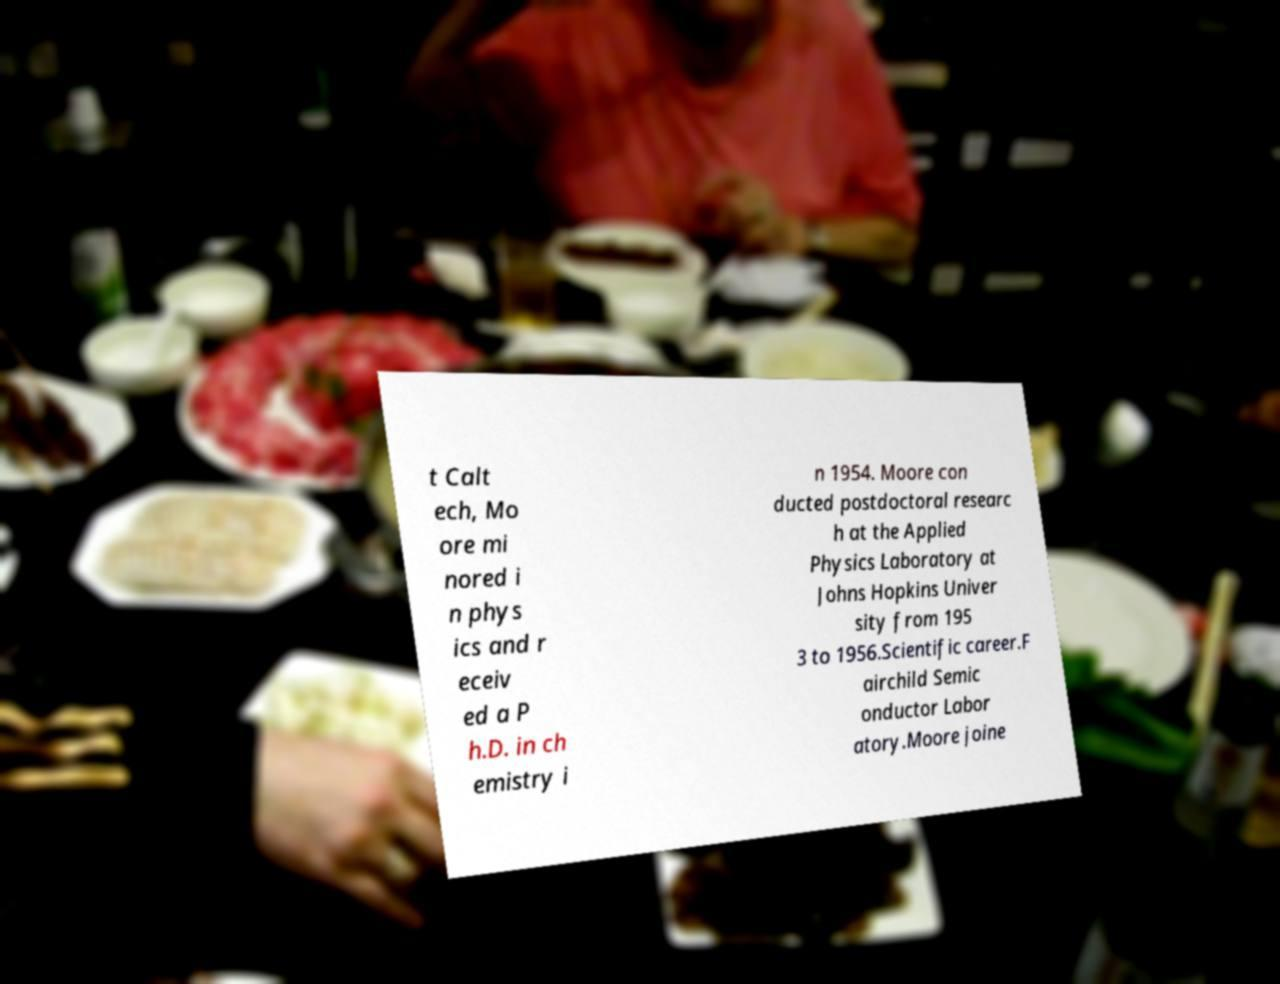Can you read and provide the text displayed in the image?This photo seems to have some interesting text. Can you extract and type it out for me? t Calt ech, Mo ore mi nored i n phys ics and r eceiv ed a P h.D. in ch emistry i n 1954. Moore con ducted postdoctoral researc h at the Applied Physics Laboratory at Johns Hopkins Univer sity from 195 3 to 1956.Scientific career.F airchild Semic onductor Labor atory.Moore joine 